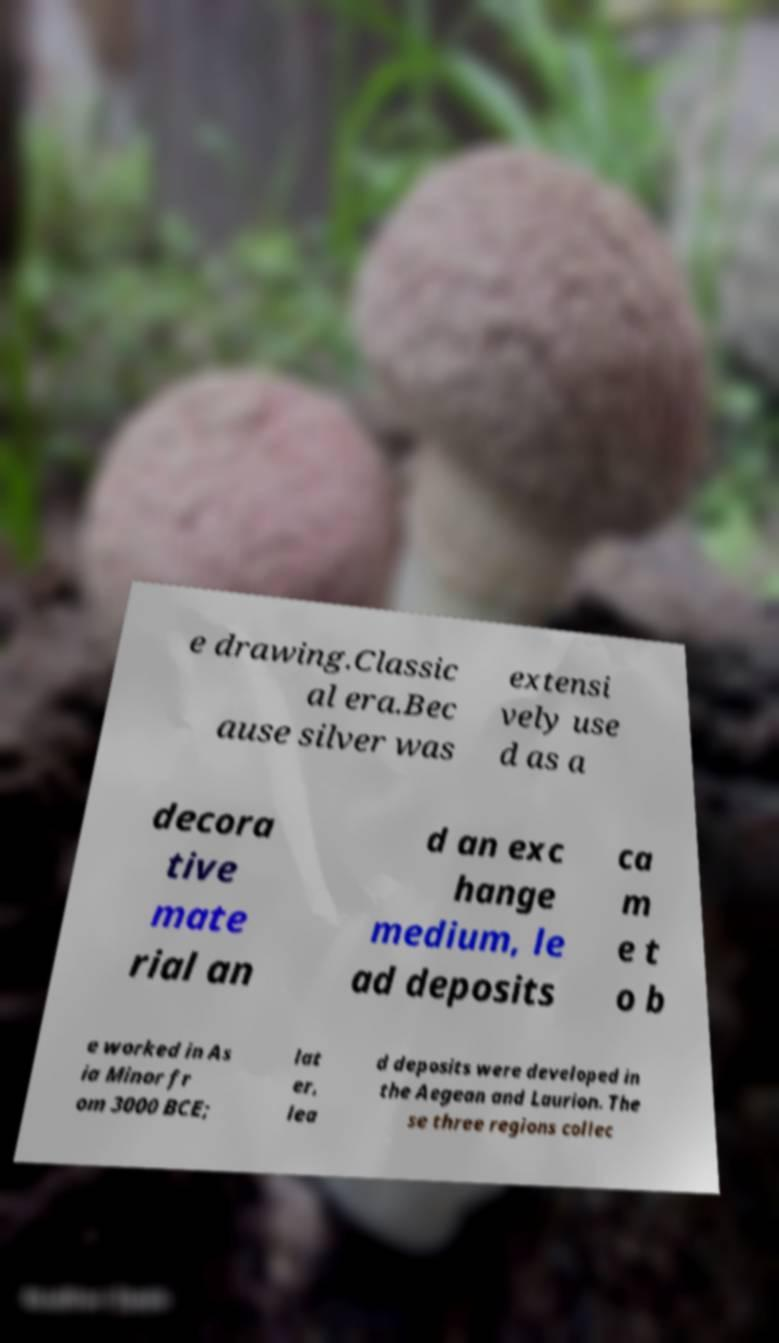I need the written content from this picture converted into text. Can you do that? e drawing.Classic al era.Bec ause silver was extensi vely use d as a decora tive mate rial an d an exc hange medium, le ad deposits ca m e t o b e worked in As ia Minor fr om 3000 BCE; lat er, lea d deposits were developed in the Aegean and Laurion. The se three regions collec 